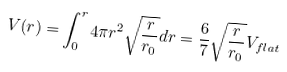Convert formula to latex. <formula><loc_0><loc_0><loc_500><loc_500>V ( r ) = \int _ { 0 } ^ { r } { 4 \pi r ^ { 2 } \sqrt { \frac { r } { r _ { 0 } } } d r } = \frac { 6 } { 7 } \sqrt { \frac { r } { r _ { 0 } } } V _ { f l a t }</formula> 